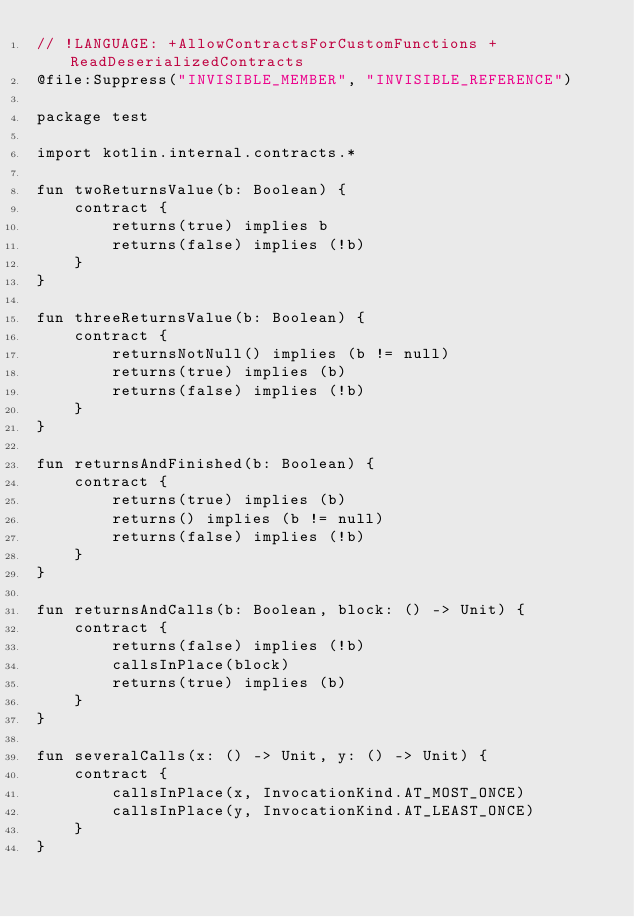<code> <loc_0><loc_0><loc_500><loc_500><_Kotlin_>// !LANGUAGE: +AllowContractsForCustomFunctions +ReadDeserializedContracts
@file:Suppress("INVISIBLE_MEMBER", "INVISIBLE_REFERENCE")

package test

import kotlin.internal.contracts.*

fun twoReturnsValue(b: Boolean) {
    contract {
        returns(true) implies b
        returns(false) implies (!b)
    }
}

fun threeReturnsValue(b: Boolean) {
    contract {
        returnsNotNull() implies (b != null)
        returns(true) implies (b)
        returns(false) implies (!b)
    }
}

fun returnsAndFinished(b: Boolean) {
    contract {
        returns(true) implies (b)
        returns() implies (b != null)
        returns(false) implies (!b)
    }
}

fun returnsAndCalls(b: Boolean, block: () -> Unit) {
    contract {
        returns(false) implies (!b)
        callsInPlace(block)
        returns(true) implies (b)
    }
}

fun severalCalls(x: () -> Unit, y: () -> Unit) {
    contract {
        callsInPlace(x, InvocationKind.AT_MOST_ONCE)
        callsInPlace(y, InvocationKind.AT_LEAST_ONCE)
    }
}</code> 